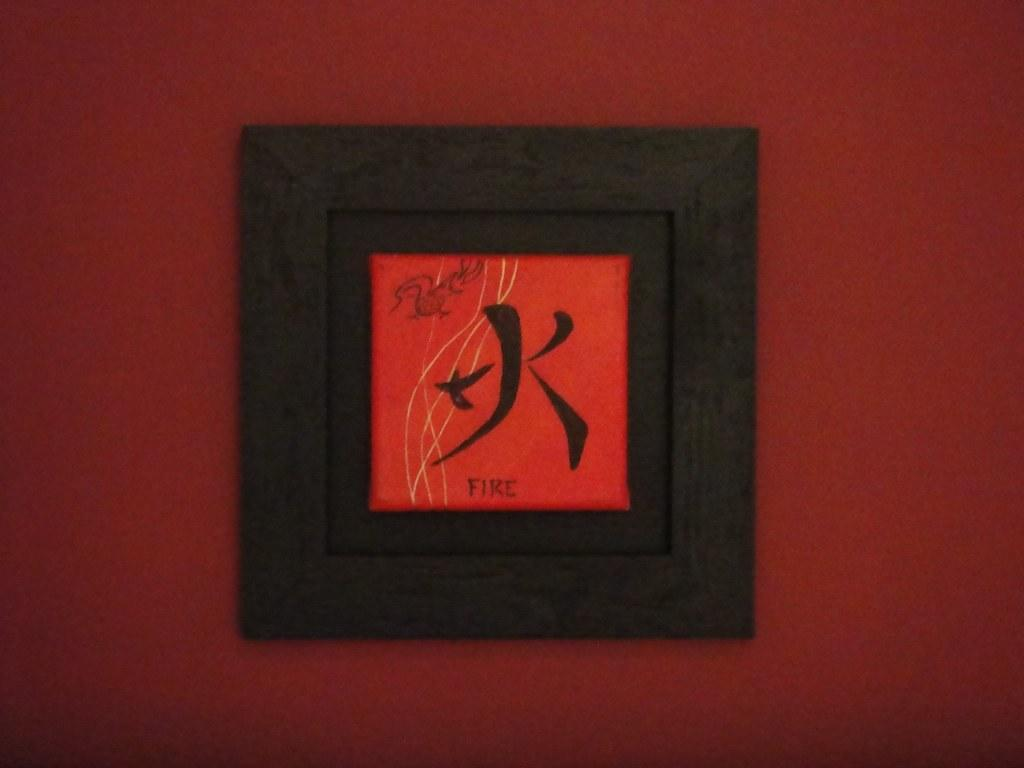<image>
Give a short and clear explanation of the subsequent image. A piece of wall art with a Chinese character and the word fire on it. 